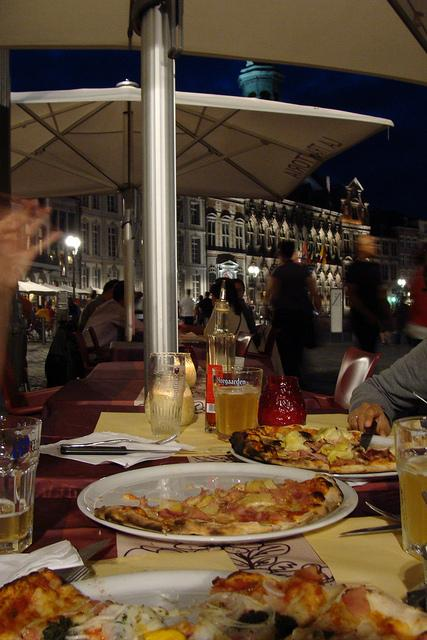What is this place? restaurant 